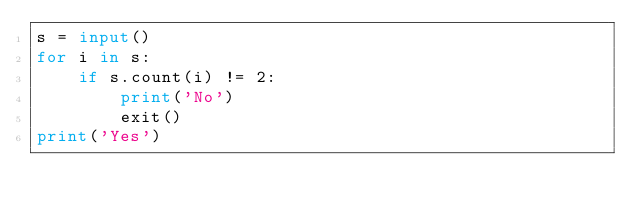<code> <loc_0><loc_0><loc_500><loc_500><_Python_>s = input()
for i in s:
    if s.count(i) != 2:
        print('No')
        exit()
print('Yes')
</code> 